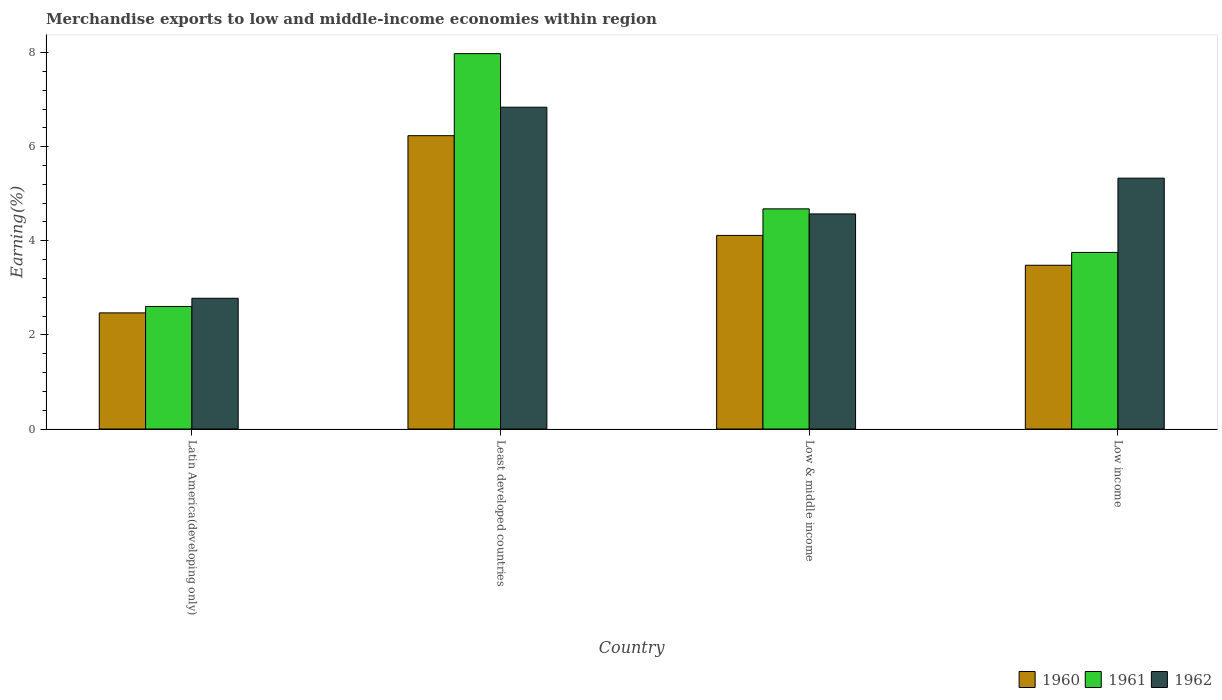How many different coloured bars are there?
Keep it short and to the point. 3. Are the number of bars per tick equal to the number of legend labels?
Your answer should be very brief. Yes. How many bars are there on the 3rd tick from the left?
Offer a very short reply. 3. How many bars are there on the 1st tick from the right?
Give a very brief answer. 3. What is the label of the 4th group of bars from the left?
Make the answer very short. Low income. What is the percentage of amount earned from merchandise exports in 1962 in Least developed countries?
Your response must be concise. 6.84. Across all countries, what is the maximum percentage of amount earned from merchandise exports in 1960?
Provide a short and direct response. 6.23. Across all countries, what is the minimum percentage of amount earned from merchandise exports in 1960?
Give a very brief answer. 2.47. In which country was the percentage of amount earned from merchandise exports in 1961 maximum?
Your answer should be compact. Least developed countries. In which country was the percentage of amount earned from merchandise exports in 1961 minimum?
Your answer should be very brief. Latin America(developing only). What is the total percentage of amount earned from merchandise exports in 1961 in the graph?
Offer a very short reply. 19.01. What is the difference between the percentage of amount earned from merchandise exports in 1960 in Latin America(developing only) and that in Low & middle income?
Give a very brief answer. -1.65. What is the difference between the percentage of amount earned from merchandise exports in 1962 in Latin America(developing only) and the percentage of amount earned from merchandise exports in 1961 in Least developed countries?
Make the answer very short. -5.2. What is the average percentage of amount earned from merchandise exports in 1960 per country?
Your answer should be compact. 4.07. What is the difference between the percentage of amount earned from merchandise exports of/in 1962 and percentage of amount earned from merchandise exports of/in 1960 in Low income?
Provide a succinct answer. 1.85. What is the ratio of the percentage of amount earned from merchandise exports in 1960 in Least developed countries to that in Low & middle income?
Offer a very short reply. 1.52. What is the difference between the highest and the second highest percentage of amount earned from merchandise exports in 1962?
Keep it short and to the point. -0.76. What is the difference between the highest and the lowest percentage of amount earned from merchandise exports in 1961?
Offer a very short reply. 5.37. Is the sum of the percentage of amount earned from merchandise exports in 1960 in Latin America(developing only) and Least developed countries greater than the maximum percentage of amount earned from merchandise exports in 1962 across all countries?
Offer a very short reply. Yes. What is the difference between two consecutive major ticks on the Y-axis?
Give a very brief answer. 2. Are the values on the major ticks of Y-axis written in scientific E-notation?
Provide a short and direct response. No. Does the graph contain any zero values?
Provide a succinct answer. No. Does the graph contain grids?
Your answer should be compact. No. How are the legend labels stacked?
Provide a succinct answer. Horizontal. What is the title of the graph?
Give a very brief answer. Merchandise exports to low and middle-income economies within region. What is the label or title of the X-axis?
Your response must be concise. Country. What is the label or title of the Y-axis?
Ensure brevity in your answer.  Earning(%). What is the Earning(%) in 1960 in Latin America(developing only)?
Provide a short and direct response. 2.47. What is the Earning(%) in 1961 in Latin America(developing only)?
Your response must be concise. 2.6. What is the Earning(%) of 1962 in Latin America(developing only)?
Offer a terse response. 2.78. What is the Earning(%) in 1960 in Least developed countries?
Offer a very short reply. 6.23. What is the Earning(%) in 1961 in Least developed countries?
Ensure brevity in your answer.  7.98. What is the Earning(%) in 1962 in Least developed countries?
Make the answer very short. 6.84. What is the Earning(%) in 1960 in Low & middle income?
Your answer should be very brief. 4.11. What is the Earning(%) in 1961 in Low & middle income?
Ensure brevity in your answer.  4.68. What is the Earning(%) of 1962 in Low & middle income?
Offer a very short reply. 4.57. What is the Earning(%) of 1960 in Low income?
Your answer should be very brief. 3.48. What is the Earning(%) of 1961 in Low income?
Your answer should be compact. 3.75. What is the Earning(%) in 1962 in Low income?
Give a very brief answer. 5.33. Across all countries, what is the maximum Earning(%) in 1960?
Keep it short and to the point. 6.23. Across all countries, what is the maximum Earning(%) of 1961?
Give a very brief answer. 7.98. Across all countries, what is the maximum Earning(%) of 1962?
Keep it short and to the point. 6.84. Across all countries, what is the minimum Earning(%) of 1960?
Give a very brief answer. 2.47. Across all countries, what is the minimum Earning(%) of 1961?
Make the answer very short. 2.6. Across all countries, what is the minimum Earning(%) of 1962?
Make the answer very short. 2.78. What is the total Earning(%) of 1960 in the graph?
Offer a terse response. 16.3. What is the total Earning(%) of 1961 in the graph?
Keep it short and to the point. 19.01. What is the total Earning(%) of 1962 in the graph?
Give a very brief answer. 19.52. What is the difference between the Earning(%) in 1960 in Latin America(developing only) and that in Least developed countries?
Your response must be concise. -3.77. What is the difference between the Earning(%) in 1961 in Latin America(developing only) and that in Least developed countries?
Offer a terse response. -5.37. What is the difference between the Earning(%) in 1962 in Latin America(developing only) and that in Least developed countries?
Provide a succinct answer. -4.06. What is the difference between the Earning(%) in 1960 in Latin America(developing only) and that in Low & middle income?
Make the answer very short. -1.65. What is the difference between the Earning(%) of 1961 in Latin America(developing only) and that in Low & middle income?
Provide a succinct answer. -2.07. What is the difference between the Earning(%) of 1962 in Latin America(developing only) and that in Low & middle income?
Make the answer very short. -1.79. What is the difference between the Earning(%) in 1960 in Latin America(developing only) and that in Low income?
Provide a short and direct response. -1.01. What is the difference between the Earning(%) of 1961 in Latin America(developing only) and that in Low income?
Give a very brief answer. -1.15. What is the difference between the Earning(%) in 1962 in Latin America(developing only) and that in Low income?
Offer a very short reply. -2.55. What is the difference between the Earning(%) of 1960 in Least developed countries and that in Low & middle income?
Give a very brief answer. 2.12. What is the difference between the Earning(%) in 1961 in Least developed countries and that in Low & middle income?
Give a very brief answer. 3.3. What is the difference between the Earning(%) of 1962 in Least developed countries and that in Low & middle income?
Provide a short and direct response. 2.27. What is the difference between the Earning(%) of 1960 in Least developed countries and that in Low income?
Your response must be concise. 2.75. What is the difference between the Earning(%) in 1961 in Least developed countries and that in Low income?
Offer a terse response. 4.22. What is the difference between the Earning(%) in 1962 in Least developed countries and that in Low income?
Offer a terse response. 1.51. What is the difference between the Earning(%) of 1960 in Low & middle income and that in Low income?
Keep it short and to the point. 0.63. What is the difference between the Earning(%) of 1961 in Low & middle income and that in Low income?
Ensure brevity in your answer.  0.93. What is the difference between the Earning(%) of 1962 in Low & middle income and that in Low income?
Your response must be concise. -0.76. What is the difference between the Earning(%) in 1960 in Latin America(developing only) and the Earning(%) in 1961 in Least developed countries?
Ensure brevity in your answer.  -5.51. What is the difference between the Earning(%) in 1960 in Latin America(developing only) and the Earning(%) in 1962 in Least developed countries?
Your answer should be very brief. -4.37. What is the difference between the Earning(%) in 1961 in Latin America(developing only) and the Earning(%) in 1962 in Least developed countries?
Make the answer very short. -4.23. What is the difference between the Earning(%) of 1960 in Latin America(developing only) and the Earning(%) of 1961 in Low & middle income?
Provide a succinct answer. -2.21. What is the difference between the Earning(%) of 1960 in Latin America(developing only) and the Earning(%) of 1962 in Low & middle income?
Give a very brief answer. -2.1. What is the difference between the Earning(%) in 1961 in Latin America(developing only) and the Earning(%) in 1962 in Low & middle income?
Offer a very short reply. -1.97. What is the difference between the Earning(%) in 1960 in Latin America(developing only) and the Earning(%) in 1961 in Low income?
Provide a succinct answer. -1.28. What is the difference between the Earning(%) in 1960 in Latin America(developing only) and the Earning(%) in 1962 in Low income?
Provide a succinct answer. -2.86. What is the difference between the Earning(%) of 1961 in Latin America(developing only) and the Earning(%) of 1962 in Low income?
Offer a very short reply. -2.73. What is the difference between the Earning(%) in 1960 in Least developed countries and the Earning(%) in 1961 in Low & middle income?
Your response must be concise. 1.56. What is the difference between the Earning(%) of 1960 in Least developed countries and the Earning(%) of 1962 in Low & middle income?
Make the answer very short. 1.66. What is the difference between the Earning(%) of 1961 in Least developed countries and the Earning(%) of 1962 in Low & middle income?
Make the answer very short. 3.41. What is the difference between the Earning(%) of 1960 in Least developed countries and the Earning(%) of 1961 in Low income?
Provide a short and direct response. 2.48. What is the difference between the Earning(%) of 1960 in Least developed countries and the Earning(%) of 1962 in Low income?
Your answer should be very brief. 0.9. What is the difference between the Earning(%) of 1961 in Least developed countries and the Earning(%) of 1962 in Low income?
Your answer should be very brief. 2.65. What is the difference between the Earning(%) in 1960 in Low & middle income and the Earning(%) in 1961 in Low income?
Offer a very short reply. 0.36. What is the difference between the Earning(%) in 1960 in Low & middle income and the Earning(%) in 1962 in Low income?
Keep it short and to the point. -1.22. What is the difference between the Earning(%) in 1961 in Low & middle income and the Earning(%) in 1962 in Low income?
Provide a succinct answer. -0.65. What is the average Earning(%) of 1960 per country?
Your response must be concise. 4.07. What is the average Earning(%) of 1961 per country?
Keep it short and to the point. 4.75. What is the average Earning(%) of 1962 per country?
Provide a short and direct response. 4.88. What is the difference between the Earning(%) of 1960 and Earning(%) of 1961 in Latin America(developing only)?
Offer a very short reply. -0.14. What is the difference between the Earning(%) in 1960 and Earning(%) in 1962 in Latin America(developing only)?
Keep it short and to the point. -0.31. What is the difference between the Earning(%) of 1961 and Earning(%) of 1962 in Latin America(developing only)?
Provide a succinct answer. -0.17. What is the difference between the Earning(%) of 1960 and Earning(%) of 1961 in Least developed countries?
Your response must be concise. -1.74. What is the difference between the Earning(%) in 1960 and Earning(%) in 1962 in Least developed countries?
Your answer should be very brief. -0.6. What is the difference between the Earning(%) of 1961 and Earning(%) of 1962 in Least developed countries?
Your answer should be compact. 1.14. What is the difference between the Earning(%) in 1960 and Earning(%) in 1961 in Low & middle income?
Ensure brevity in your answer.  -0.56. What is the difference between the Earning(%) in 1960 and Earning(%) in 1962 in Low & middle income?
Offer a terse response. -0.46. What is the difference between the Earning(%) in 1961 and Earning(%) in 1962 in Low & middle income?
Your answer should be compact. 0.11. What is the difference between the Earning(%) of 1960 and Earning(%) of 1961 in Low income?
Give a very brief answer. -0.27. What is the difference between the Earning(%) in 1960 and Earning(%) in 1962 in Low income?
Make the answer very short. -1.85. What is the difference between the Earning(%) in 1961 and Earning(%) in 1962 in Low income?
Offer a very short reply. -1.58. What is the ratio of the Earning(%) of 1960 in Latin America(developing only) to that in Least developed countries?
Your response must be concise. 0.4. What is the ratio of the Earning(%) in 1961 in Latin America(developing only) to that in Least developed countries?
Offer a very short reply. 0.33. What is the ratio of the Earning(%) of 1962 in Latin America(developing only) to that in Least developed countries?
Provide a short and direct response. 0.41. What is the ratio of the Earning(%) in 1960 in Latin America(developing only) to that in Low & middle income?
Your answer should be very brief. 0.6. What is the ratio of the Earning(%) in 1961 in Latin America(developing only) to that in Low & middle income?
Provide a short and direct response. 0.56. What is the ratio of the Earning(%) of 1962 in Latin America(developing only) to that in Low & middle income?
Your answer should be very brief. 0.61. What is the ratio of the Earning(%) of 1960 in Latin America(developing only) to that in Low income?
Provide a succinct answer. 0.71. What is the ratio of the Earning(%) in 1961 in Latin America(developing only) to that in Low income?
Your response must be concise. 0.69. What is the ratio of the Earning(%) in 1962 in Latin America(developing only) to that in Low income?
Keep it short and to the point. 0.52. What is the ratio of the Earning(%) of 1960 in Least developed countries to that in Low & middle income?
Provide a short and direct response. 1.52. What is the ratio of the Earning(%) of 1961 in Least developed countries to that in Low & middle income?
Your answer should be compact. 1.71. What is the ratio of the Earning(%) in 1962 in Least developed countries to that in Low & middle income?
Provide a short and direct response. 1.5. What is the ratio of the Earning(%) of 1960 in Least developed countries to that in Low income?
Offer a very short reply. 1.79. What is the ratio of the Earning(%) in 1961 in Least developed countries to that in Low income?
Make the answer very short. 2.13. What is the ratio of the Earning(%) of 1962 in Least developed countries to that in Low income?
Ensure brevity in your answer.  1.28. What is the ratio of the Earning(%) of 1960 in Low & middle income to that in Low income?
Make the answer very short. 1.18. What is the ratio of the Earning(%) in 1961 in Low & middle income to that in Low income?
Make the answer very short. 1.25. What is the ratio of the Earning(%) in 1962 in Low & middle income to that in Low income?
Give a very brief answer. 0.86. What is the difference between the highest and the second highest Earning(%) of 1960?
Provide a succinct answer. 2.12. What is the difference between the highest and the second highest Earning(%) of 1961?
Your answer should be very brief. 3.3. What is the difference between the highest and the second highest Earning(%) in 1962?
Make the answer very short. 1.51. What is the difference between the highest and the lowest Earning(%) in 1960?
Your answer should be compact. 3.77. What is the difference between the highest and the lowest Earning(%) of 1961?
Keep it short and to the point. 5.37. What is the difference between the highest and the lowest Earning(%) of 1962?
Provide a succinct answer. 4.06. 